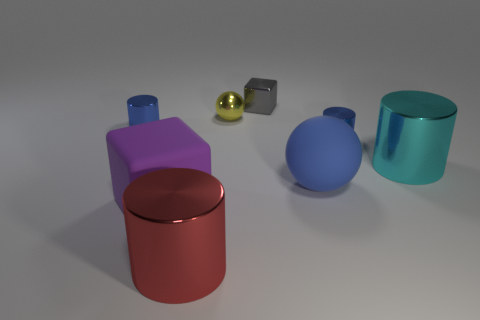Subtract 1 cylinders. How many cylinders are left? 3 Add 2 big blue rubber cubes. How many objects exist? 10 Subtract all cubes. How many objects are left? 6 Subtract 0 purple balls. How many objects are left? 8 Subtract all large matte balls. Subtract all tiny purple rubber blocks. How many objects are left? 7 Add 8 small shiny cylinders. How many small shiny cylinders are left? 10 Add 1 yellow shiny things. How many yellow shiny things exist? 2 